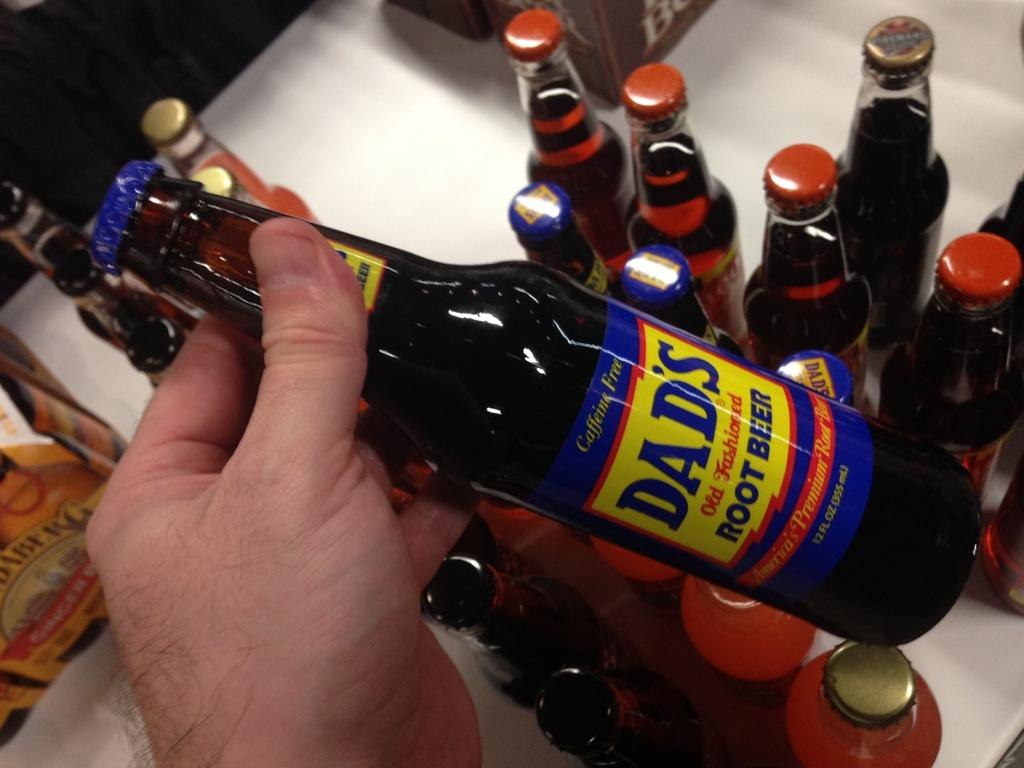<image>
Create a compact narrative representing the image presented. Someone is holding a bottle of Das Old Fashioned Root Beer above a number of other bottles. 